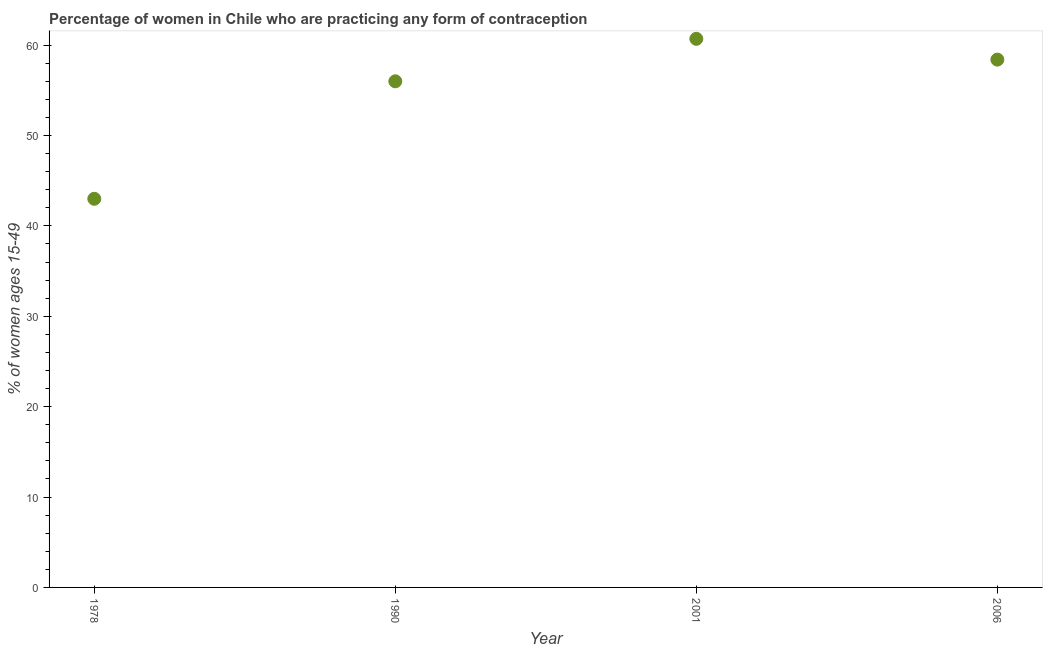What is the contraceptive prevalence in 2001?
Your answer should be very brief. 60.7. Across all years, what is the maximum contraceptive prevalence?
Ensure brevity in your answer.  60.7. Across all years, what is the minimum contraceptive prevalence?
Offer a very short reply. 43. In which year was the contraceptive prevalence maximum?
Your answer should be very brief. 2001. In which year was the contraceptive prevalence minimum?
Give a very brief answer. 1978. What is the sum of the contraceptive prevalence?
Your response must be concise. 218.1. What is the average contraceptive prevalence per year?
Give a very brief answer. 54.52. What is the median contraceptive prevalence?
Keep it short and to the point. 57.2. What is the ratio of the contraceptive prevalence in 1978 to that in 1990?
Your response must be concise. 0.77. Is the contraceptive prevalence in 1978 less than that in 2001?
Give a very brief answer. Yes. What is the difference between the highest and the second highest contraceptive prevalence?
Your answer should be very brief. 2.3. What is the difference between the highest and the lowest contraceptive prevalence?
Offer a very short reply. 17.7. In how many years, is the contraceptive prevalence greater than the average contraceptive prevalence taken over all years?
Provide a short and direct response. 3. Does the contraceptive prevalence monotonically increase over the years?
Provide a succinct answer. No. How many dotlines are there?
Provide a short and direct response. 1. How many years are there in the graph?
Your answer should be very brief. 4. Does the graph contain grids?
Offer a terse response. No. What is the title of the graph?
Offer a very short reply. Percentage of women in Chile who are practicing any form of contraception. What is the label or title of the Y-axis?
Offer a terse response. % of women ages 15-49. What is the % of women ages 15-49 in 2001?
Give a very brief answer. 60.7. What is the % of women ages 15-49 in 2006?
Your answer should be very brief. 58.4. What is the difference between the % of women ages 15-49 in 1978 and 1990?
Make the answer very short. -13. What is the difference between the % of women ages 15-49 in 1978 and 2001?
Provide a succinct answer. -17.7. What is the difference between the % of women ages 15-49 in 1978 and 2006?
Provide a short and direct response. -15.4. What is the difference between the % of women ages 15-49 in 1990 and 2001?
Ensure brevity in your answer.  -4.7. What is the difference between the % of women ages 15-49 in 2001 and 2006?
Give a very brief answer. 2.3. What is the ratio of the % of women ages 15-49 in 1978 to that in 1990?
Ensure brevity in your answer.  0.77. What is the ratio of the % of women ages 15-49 in 1978 to that in 2001?
Keep it short and to the point. 0.71. What is the ratio of the % of women ages 15-49 in 1978 to that in 2006?
Keep it short and to the point. 0.74. What is the ratio of the % of women ages 15-49 in 1990 to that in 2001?
Your response must be concise. 0.92. What is the ratio of the % of women ages 15-49 in 1990 to that in 2006?
Keep it short and to the point. 0.96. What is the ratio of the % of women ages 15-49 in 2001 to that in 2006?
Your response must be concise. 1.04. 